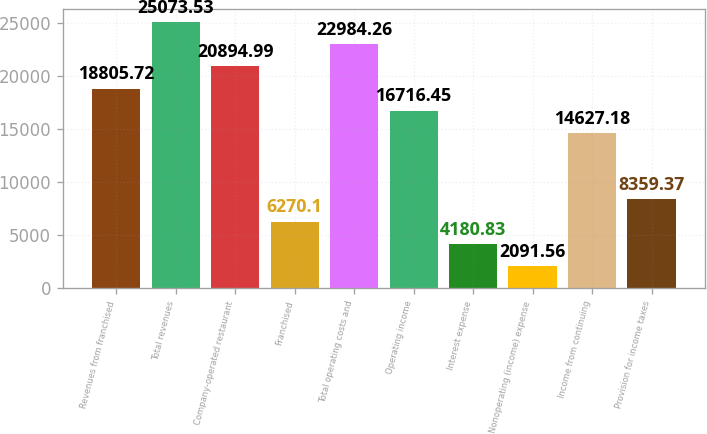Convert chart to OTSL. <chart><loc_0><loc_0><loc_500><loc_500><bar_chart><fcel>Revenues from franchised<fcel>Total revenues<fcel>Company-operated restaurant<fcel>Franchised<fcel>Total operating costs and<fcel>Operating income<fcel>Interest expense<fcel>Nonoperating (income) expense<fcel>Income from continuing<fcel>Provision for income taxes<nl><fcel>18805.7<fcel>25073.5<fcel>20895<fcel>6270.1<fcel>22984.3<fcel>16716.5<fcel>4180.83<fcel>2091.56<fcel>14627.2<fcel>8359.37<nl></chart> 